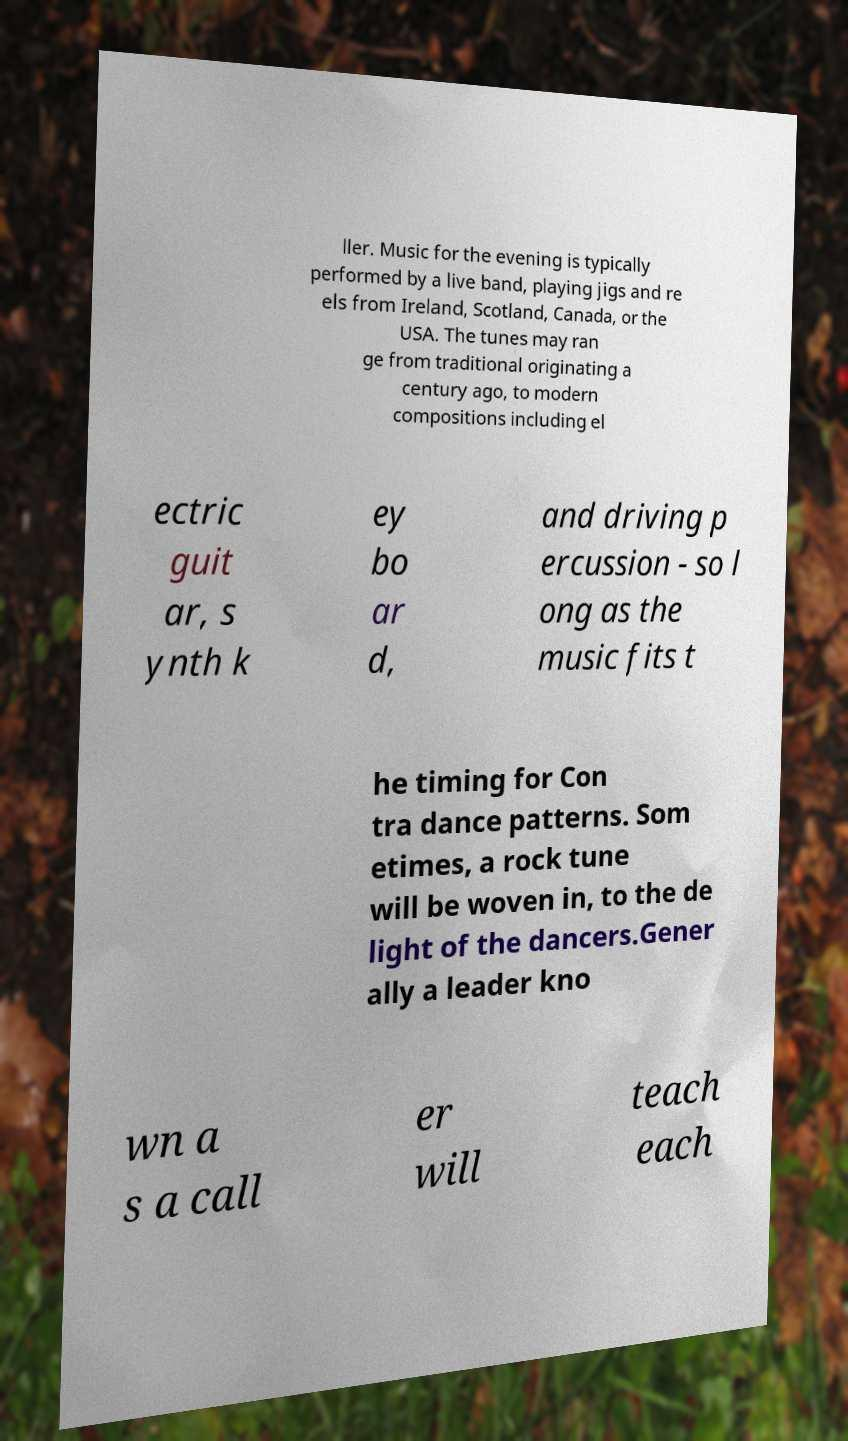There's text embedded in this image that I need extracted. Can you transcribe it verbatim? ller. Music for the evening is typically performed by a live band, playing jigs and re els from Ireland, Scotland, Canada, or the USA. The tunes may ran ge from traditional originating a century ago, to modern compositions including el ectric guit ar, s ynth k ey bo ar d, and driving p ercussion - so l ong as the music fits t he timing for Con tra dance patterns. Som etimes, a rock tune will be woven in, to the de light of the dancers.Gener ally a leader kno wn a s a call er will teach each 